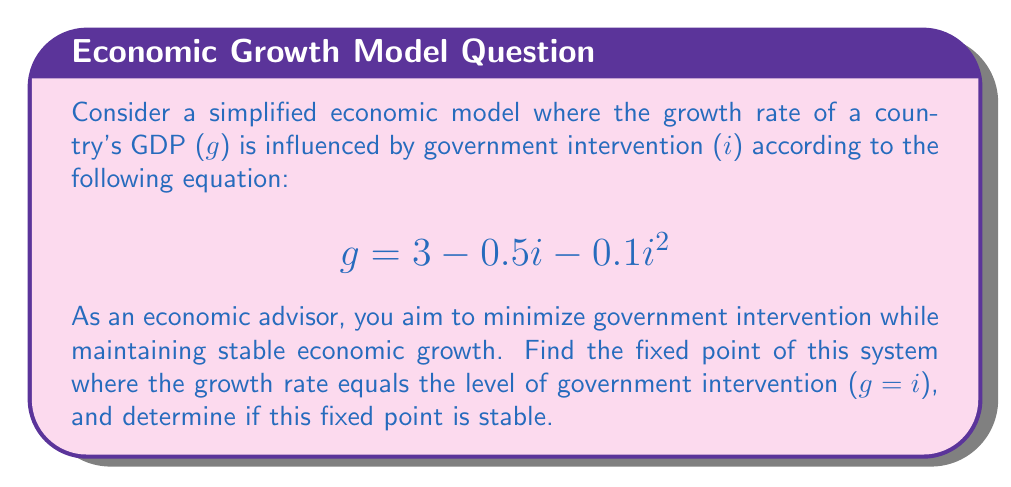Provide a solution to this math problem. 1) To find the fixed point, we set $g = i$:

   $$i = 3 - 0.5i - 0.1i^2$$

2) Rearrange the equation:

   $$0.1i^2 + 1.5i - 3 = 0$$

3) This is a quadratic equation. We can solve it using the quadratic formula:
   $$i = \frac{-b \pm \sqrt{b^2 - 4ac}}{2a}$$
   where $a = 0.1$, $b = 1.5$, and $c = -3$

4) Plugging in the values:

   $$i = \frac{-1.5 \pm \sqrt{1.5^2 - 4(0.1)(-3)}}{2(0.1)}$$

5) Simplifying:

   $$i = \frac{-1.5 \pm \sqrt{2.25 + 1.2}}{0.2} = \frac{-1.5 \pm \sqrt{3.45}}{0.2}$$

6) Calculating:

   $$i \approx 1.57 \text{ or } i \approx -19.07$$

   We discard the negative solution as it's not economically meaningful.

7) To check stability, we examine the derivative of the function at the fixed point:

   $$\frac{dg}{di} = -0.5 - 0.2i$$

8) At $i = 1.57$:

   $$\frac{dg}{di} \approx -0.5 - 0.2(1.57) \approx -0.814$$

9) Since $|\frac{dg}{di}| < 1$ at the fixed point, it is stable.
Answer: Stable fixed point at $i \approx 1.57$ 